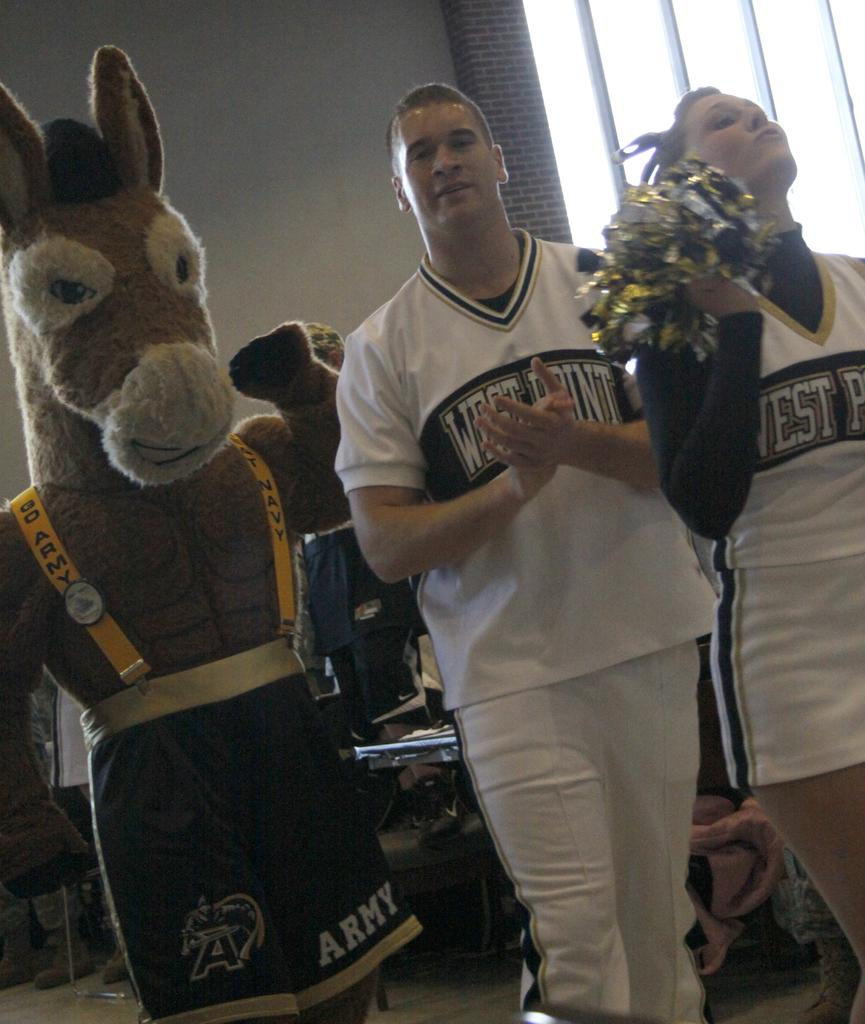<image>
Offer a succinct explanation of the picture presented. The donkey mascot's shorts has the word "army" on them. 